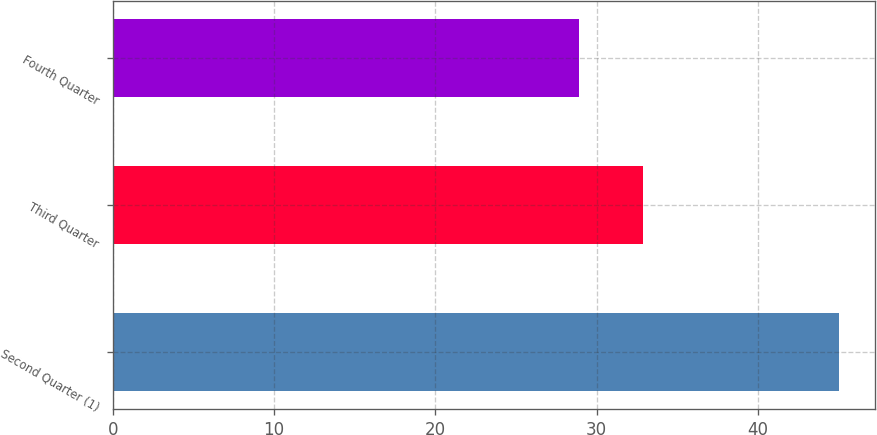Convert chart to OTSL. <chart><loc_0><loc_0><loc_500><loc_500><bar_chart><fcel>Second Quarter (1)<fcel>Third Quarter<fcel>Fourth Quarter<nl><fcel>45<fcel>32.88<fcel>28.88<nl></chart> 